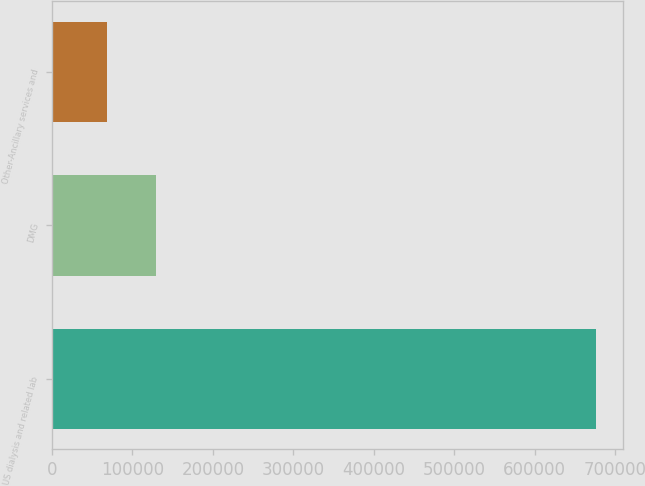Convert chart. <chart><loc_0><loc_0><loc_500><loc_500><bar_chart><fcel>US dialysis and related lab<fcel>DMG<fcel>Other-Ancillary services and<nl><fcel>675994<fcel>129431<fcel>68702<nl></chart> 